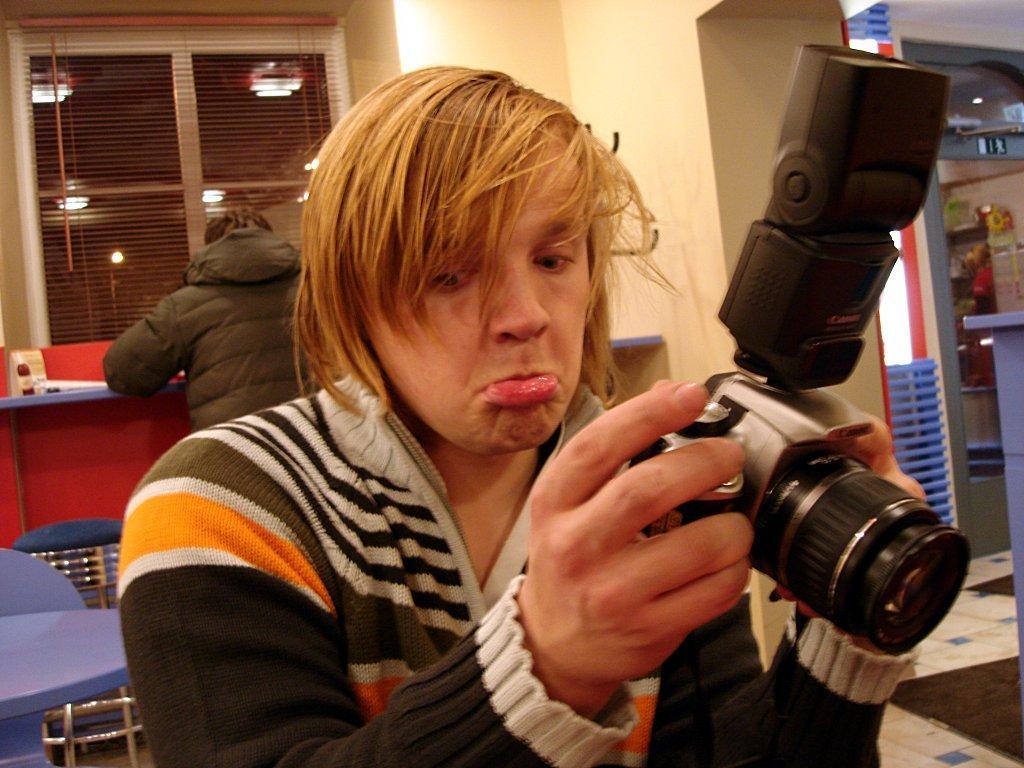In one or two sentences, can you explain what this image depicts? This is a picture of a person holding the camera in his hand and in the background there is another person , window , chair , table. 